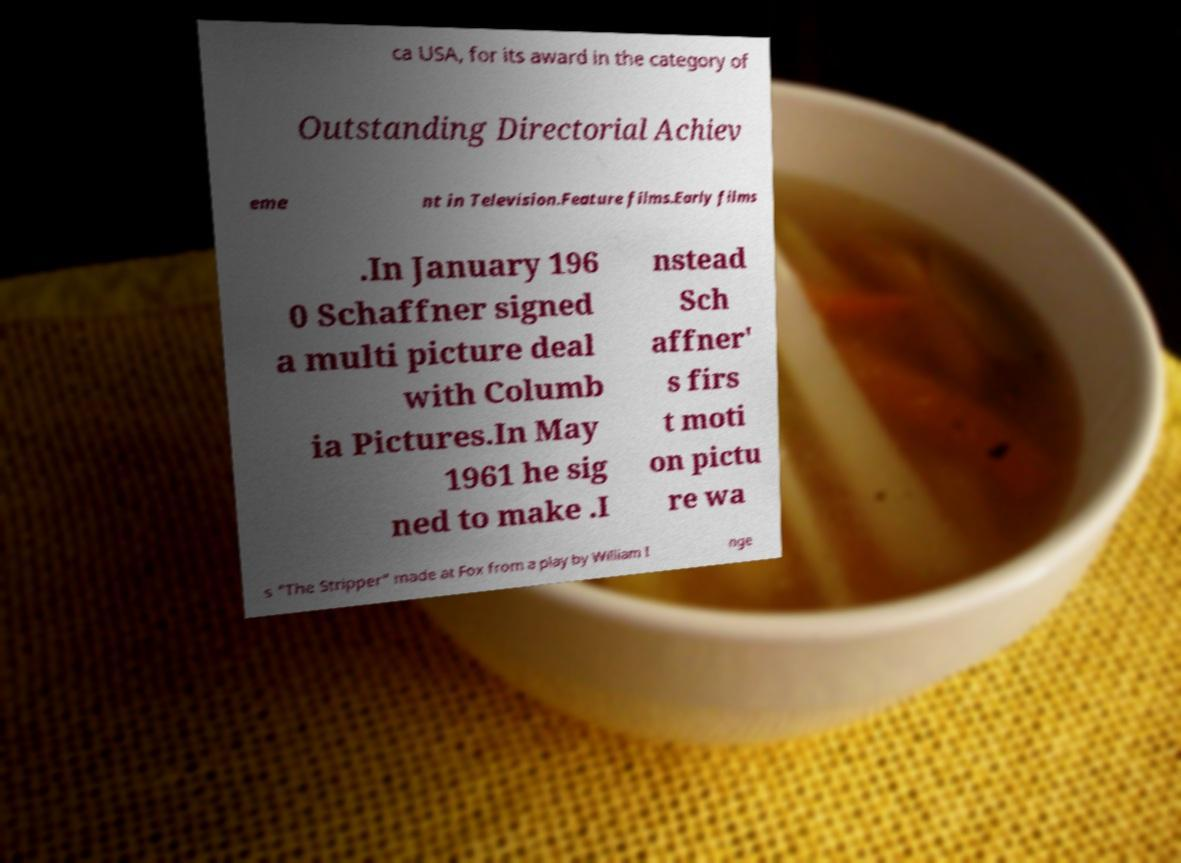Can you read and provide the text displayed in the image?This photo seems to have some interesting text. Can you extract and type it out for me? ca USA, for its award in the category of Outstanding Directorial Achiev eme nt in Television.Feature films.Early films .In January 196 0 Schaffner signed a multi picture deal with Columb ia Pictures.In May 1961 he sig ned to make .I nstead Sch affner' s firs t moti on pictu re wa s "The Stripper" made at Fox from a play by William I nge 